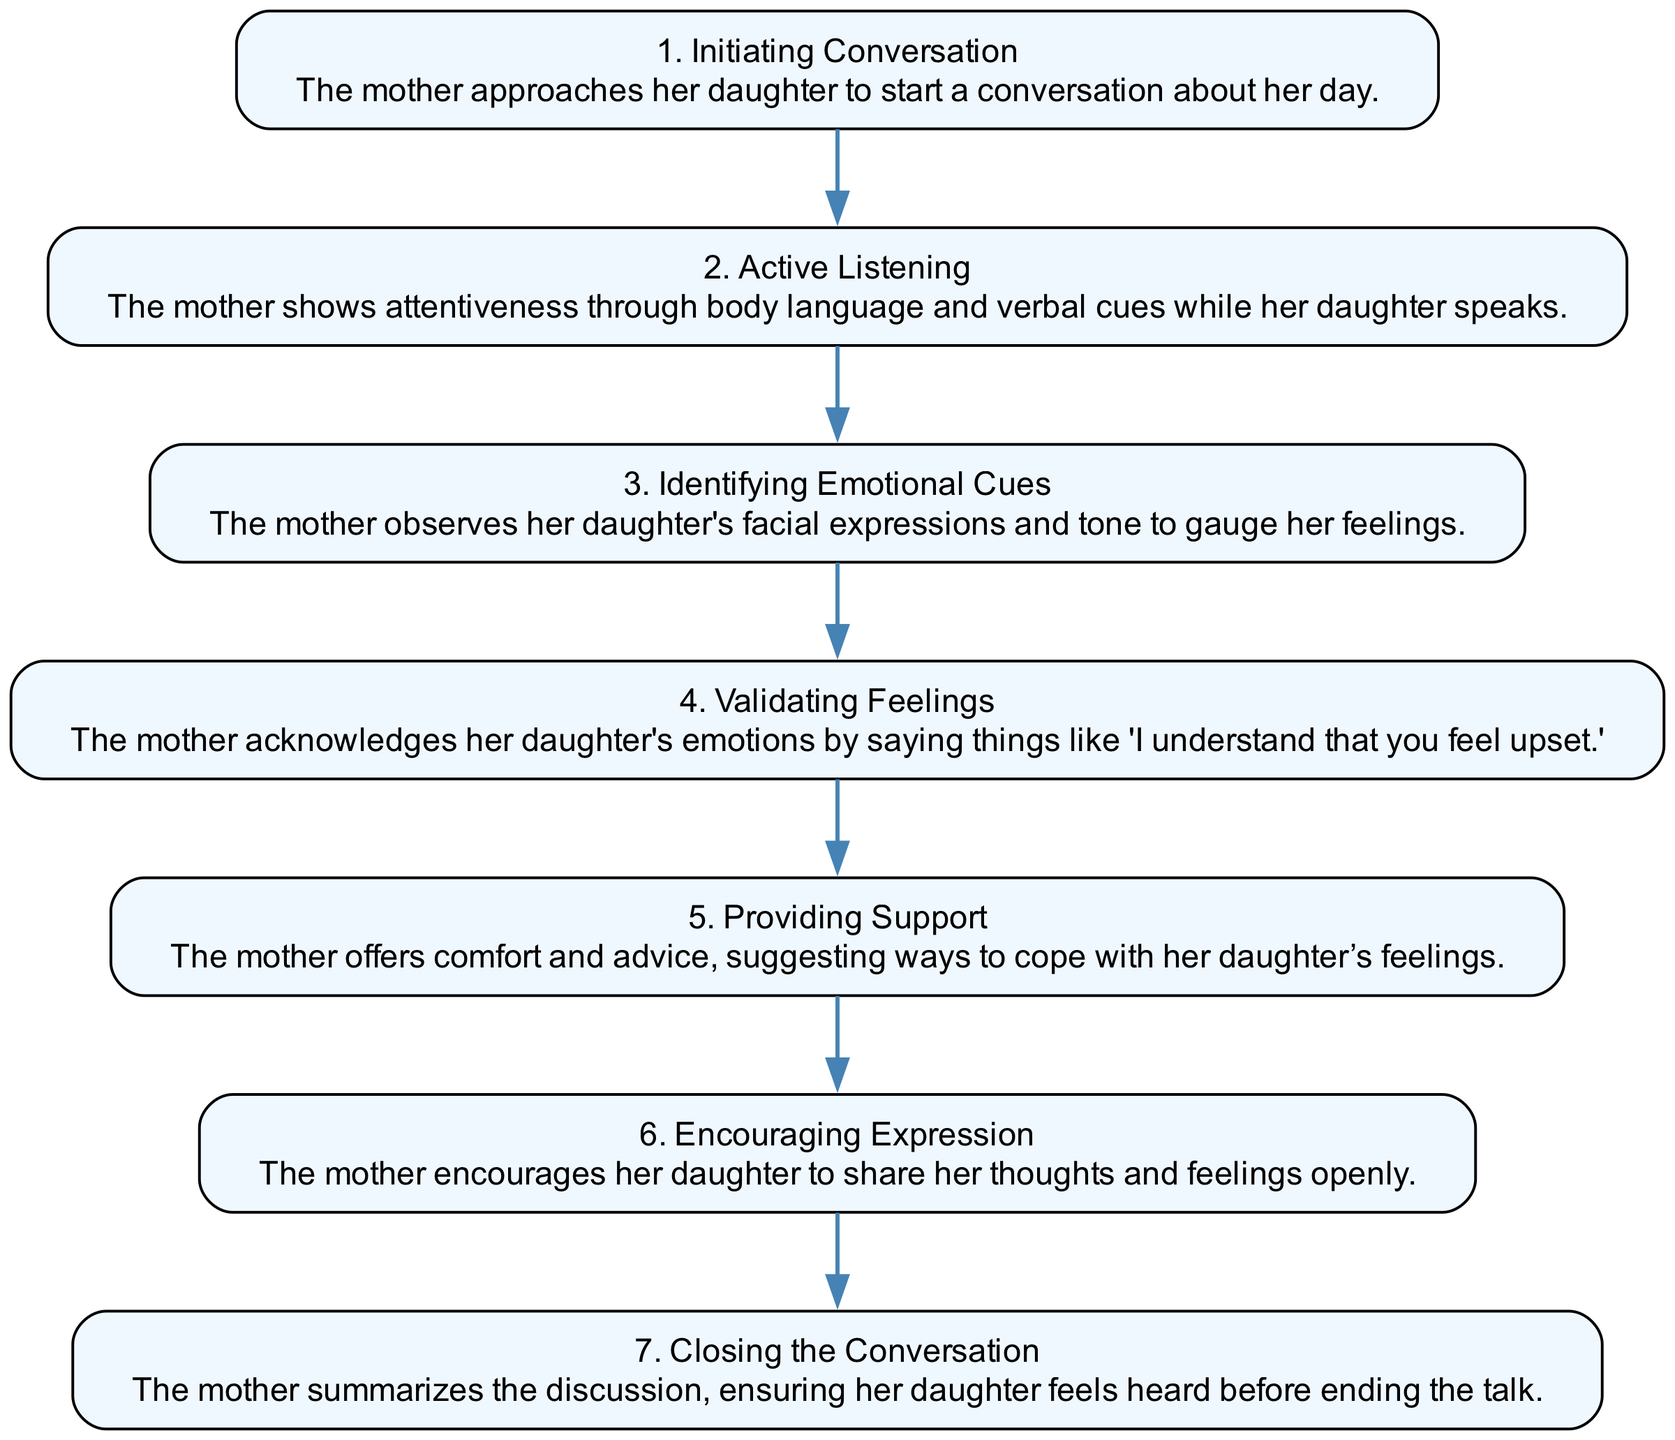What is the first step in the process? The first step in the sequence diagram is "Initiating Conversation," where the mother approaches her daughter to start a conversation about her day.
Answer: Initiating Conversation How many steps are shown in the diagram? The diagram contains a total of 7 steps, which cover various stages of the conversation process between the mother and daughter.
Answer: 7 What does the mother do after "Active Listening"? After "Active Listening," the next step is "Identifying Emotional Cues," indicating that the mother observes her daughter's expressions and tone to gauge her feelings.
Answer: Identifying Emotional Cues What step involves offering advice? The step that involves offering advice is "Providing Support," where the mother suggests ways to cope with her daughter's feelings.
Answer: Providing Support Which step comes before "Closing the Conversation"? The step that comes immediately before "Closing the Conversation" is "Encouraging Expression," where the mother encourages her daughter to share her thoughts and feelings openly.
Answer: Encouraging Expression What emotion is acknowledged in "Validating Feelings"? In "Validating Feelings," the mother acknowledges her daughter's emotions, for example, by saying things like "I understand that you feel upset."
Answer: Upset What is the relationship between "Identifying Emotional Cues" and "Validating Feelings"? "Identifying Emotional Cues" occurs prior to "Validating Feelings," as understanding her daughter's feelings is necessary before the mother can acknowledge them.
Answer: Sequential relationship 